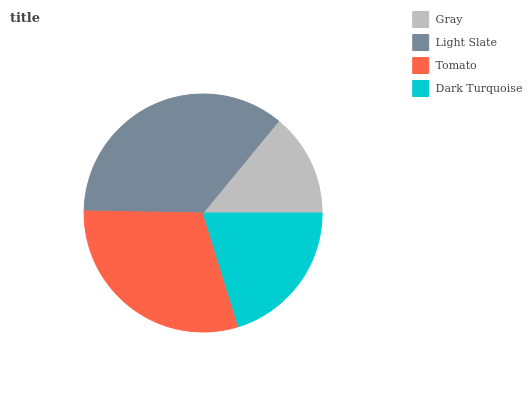Is Gray the minimum?
Answer yes or no. Yes. Is Light Slate the maximum?
Answer yes or no. Yes. Is Tomato the minimum?
Answer yes or no. No. Is Tomato the maximum?
Answer yes or no. No. Is Light Slate greater than Tomato?
Answer yes or no. Yes. Is Tomato less than Light Slate?
Answer yes or no. Yes. Is Tomato greater than Light Slate?
Answer yes or no. No. Is Light Slate less than Tomato?
Answer yes or no. No. Is Tomato the high median?
Answer yes or no. Yes. Is Dark Turquoise the low median?
Answer yes or no. Yes. Is Gray the high median?
Answer yes or no. No. Is Tomato the low median?
Answer yes or no. No. 